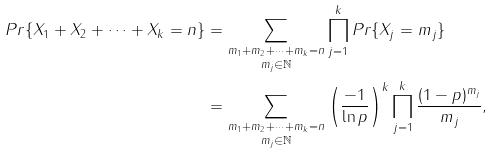<formula> <loc_0><loc_0><loc_500><loc_500>P r \{ X _ { 1 } + X _ { 2 } + \dots + X _ { k } = n \} & = \underset { m _ { j } \in \mathbb { N } } { \underset { m _ { 1 } + m _ { 2 } + \dots + m _ { k } = n } { \sum } } \prod _ { j = 1 } ^ { k } P r \{ X _ { j } = m _ { j } \} \\ & = \underset { m _ { j } \in \mathbb { N } } { \underset { m _ { 1 } + m _ { 2 } + \dots + m _ { k } = n } { \sum } } \left ( \frac { - 1 } { \ln p } \right ) ^ { k } \prod _ { j = 1 } ^ { k } \frac { ( 1 - p ) ^ { m _ { j } } } { m _ { j } } ,</formula> 